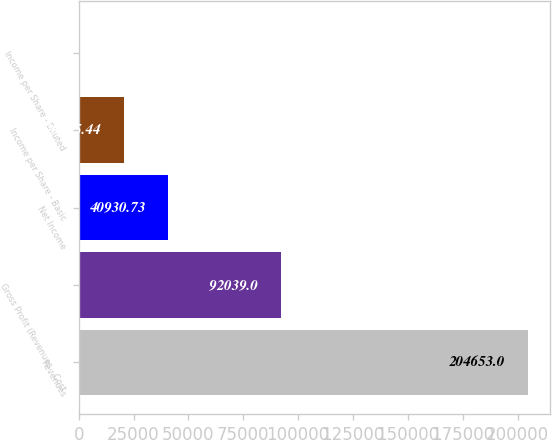Convert chart. <chart><loc_0><loc_0><loc_500><loc_500><bar_chart><fcel>Revenues<fcel>Gross Profit (Revenues - Cost<fcel>Net Income<fcel>Income per Share - Basic<fcel>Income per Share - Diluted<nl><fcel>204653<fcel>92039<fcel>40930.7<fcel>20465.4<fcel>0.15<nl></chart> 